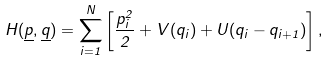Convert formula to latex. <formula><loc_0><loc_0><loc_500><loc_500>H ( \underline { p } , \underline { q } ) = \sum _ { i = 1 } ^ { N } \left [ \frac { p _ { i } ^ { 2 } } { 2 } + V ( q _ { i } ) + U ( q _ { i } - q _ { i + 1 } ) \right ] ,</formula> 